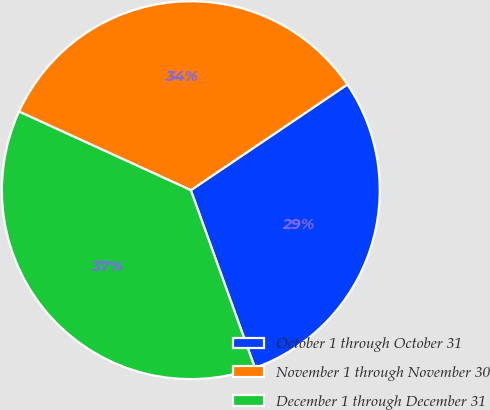Convert chart to OTSL. <chart><loc_0><loc_0><loc_500><loc_500><pie_chart><fcel>October 1 through October 31<fcel>November 1 through November 30<fcel>December 1 through December 31<nl><fcel>28.94%<fcel>33.72%<fcel>37.34%<nl></chart> 